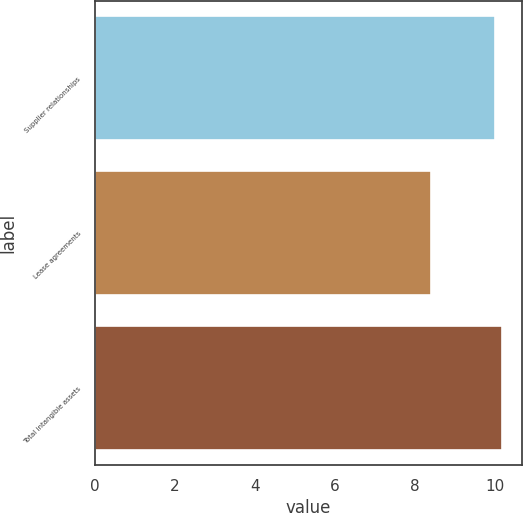<chart> <loc_0><loc_0><loc_500><loc_500><bar_chart><fcel>Supplier relationships<fcel>Lease agreements<fcel>Total intangible assets<nl><fcel>10<fcel>8.4<fcel>10.16<nl></chart> 